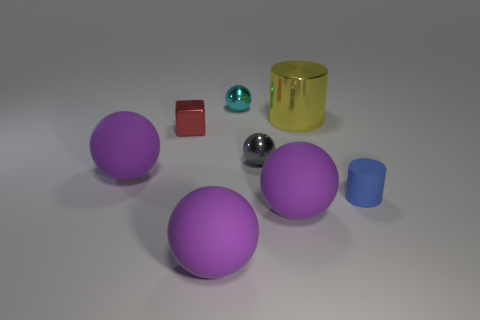Subtract all purple matte balls. How many balls are left? 2 Add 1 red metal blocks. How many objects exist? 9 Subtract all purple blocks. How many purple balls are left? 3 Subtract 1 spheres. How many spheres are left? 4 Subtract all blue cylinders. How many cylinders are left? 1 Subtract all spheres. How many objects are left? 3 Subtract all big purple matte balls. Subtract all metal balls. How many objects are left? 3 Add 2 small balls. How many small balls are left? 4 Add 4 large yellow metal cubes. How many large yellow metal cubes exist? 4 Subtract 0 cyan cubes. How many objects are left? 8 